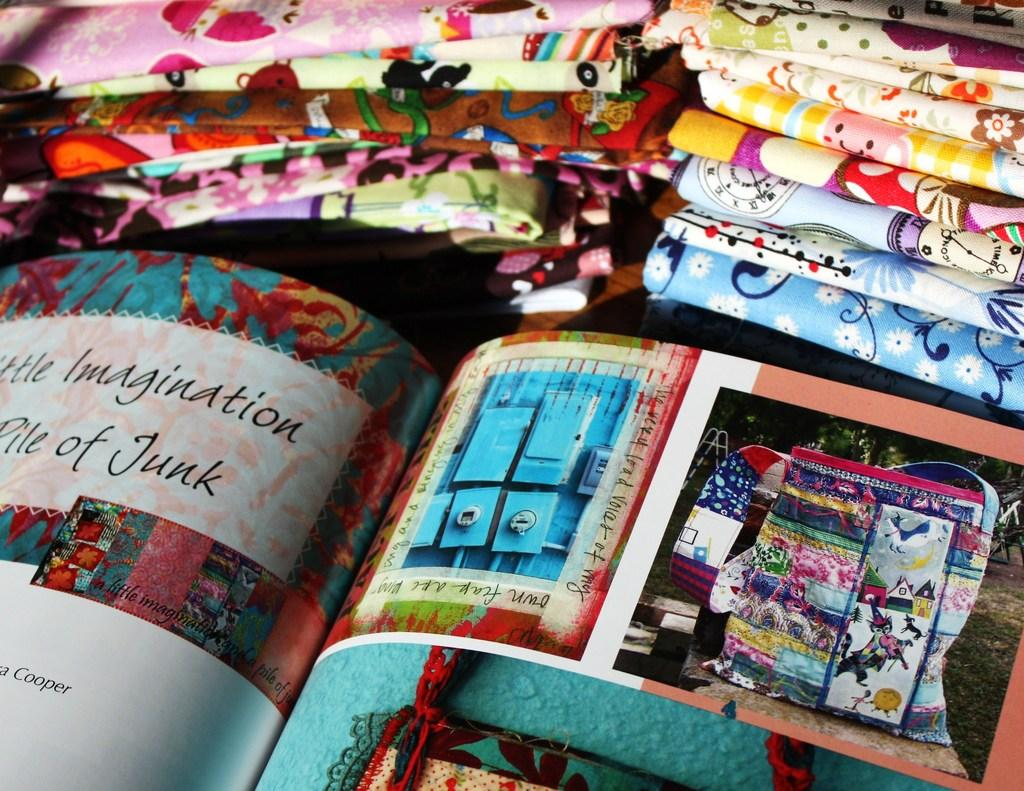<image>
Relay a brief, clear account of the picture shown. The last name of the artist who did this work is Cooper 